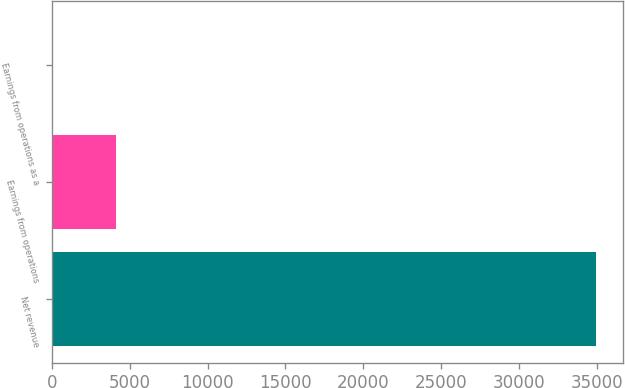Convert chart. <chart><loc_0><loc_0><loc_500><loc_500><bar_chart><fcel>Net revenue<fcel>Earnings from operations<fcel>Earnings from operations as a<nl><fcel>34922<fcel>4095<fcel>11.7<nl></chart> 